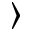Convert formula to latex. <formula><loc_0><loc_0><loc_500><loc_500>\rangle</formula> 